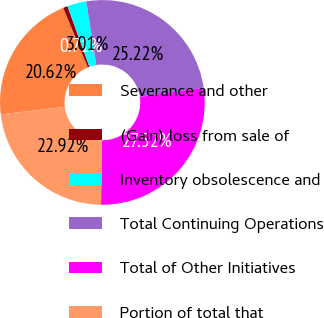Convert chart to OTSL. <chart><loc_0><loc_0><loc_500><loc_500><pie_chart><fcel>Severance and other<fcel>(Gain) loss from sale of<fcel>Inventory obsolescence and<fcel>Total Continuing Operations<fcel>Total of Other Initiatives<fcel>Portion of total that<nl><fcel>20.62%<fcel>0.71%<fcel>3.01%<fcel>25.22%<fcel>27.52%<fcel>22.92%<nl></chart> 